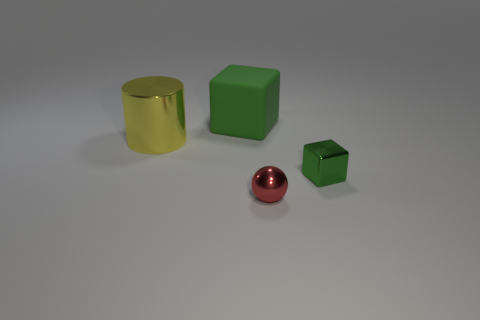What is the shape of the yellow metallic thing?
Your response must be concise. Cylinder. There is a matte cube that is the same color as the metallic block; what size is it?
Keep it short and to the point. Large. There is a object on the left side of the cube that is behind the tiny green cube; what is its size?
Provide a short and direct response. Large. How big is the green block to the left of the green metallic cube?
Your answer should be compact. Large. Is the number of green objects right of the small green metal cube less than the number of green things that are behind the metal cylinder?
Your answer should be compact. Yes. What is the color of the small metal sphere?
Ensure brevity in your answer.  Red. Are there any small objects of the same color as the matte block?
Your response must be concise. Yes. There is a green thing that is on the left side of the green thing in front of the object on the left side of the big green matte block; what shape is it?
Your answer should be very brief. Cube. There is a tiny thing that is in front of the metallic block; what is it made of?
Ensure brevity in your answer.  Metal. There is a metallic thing in front of the cube on the right side of the large thing behind the big cylinder; how big is it?
Provide a short and direct response. Small. 